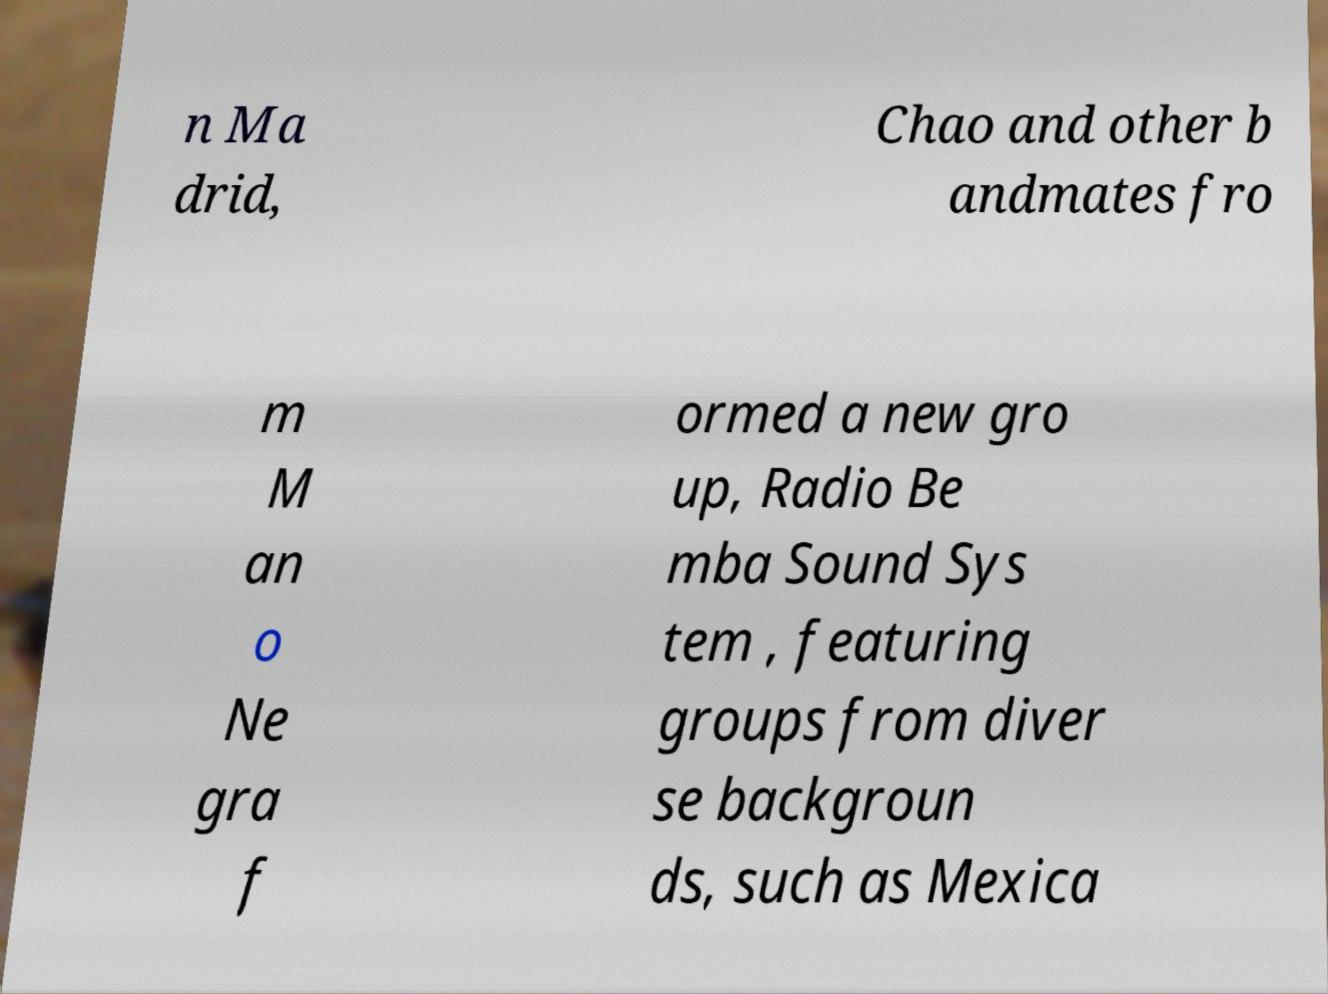There's text embedded in this image that I need extracted. Can you transcribe it verbatim? n Ma drid, Chao and other b andmates fro m M an o Ne gra f ormed a new gro up, Radio Be mba Sound Sys tem , featuring groups from diver se backgroun ds, such as Mexica 